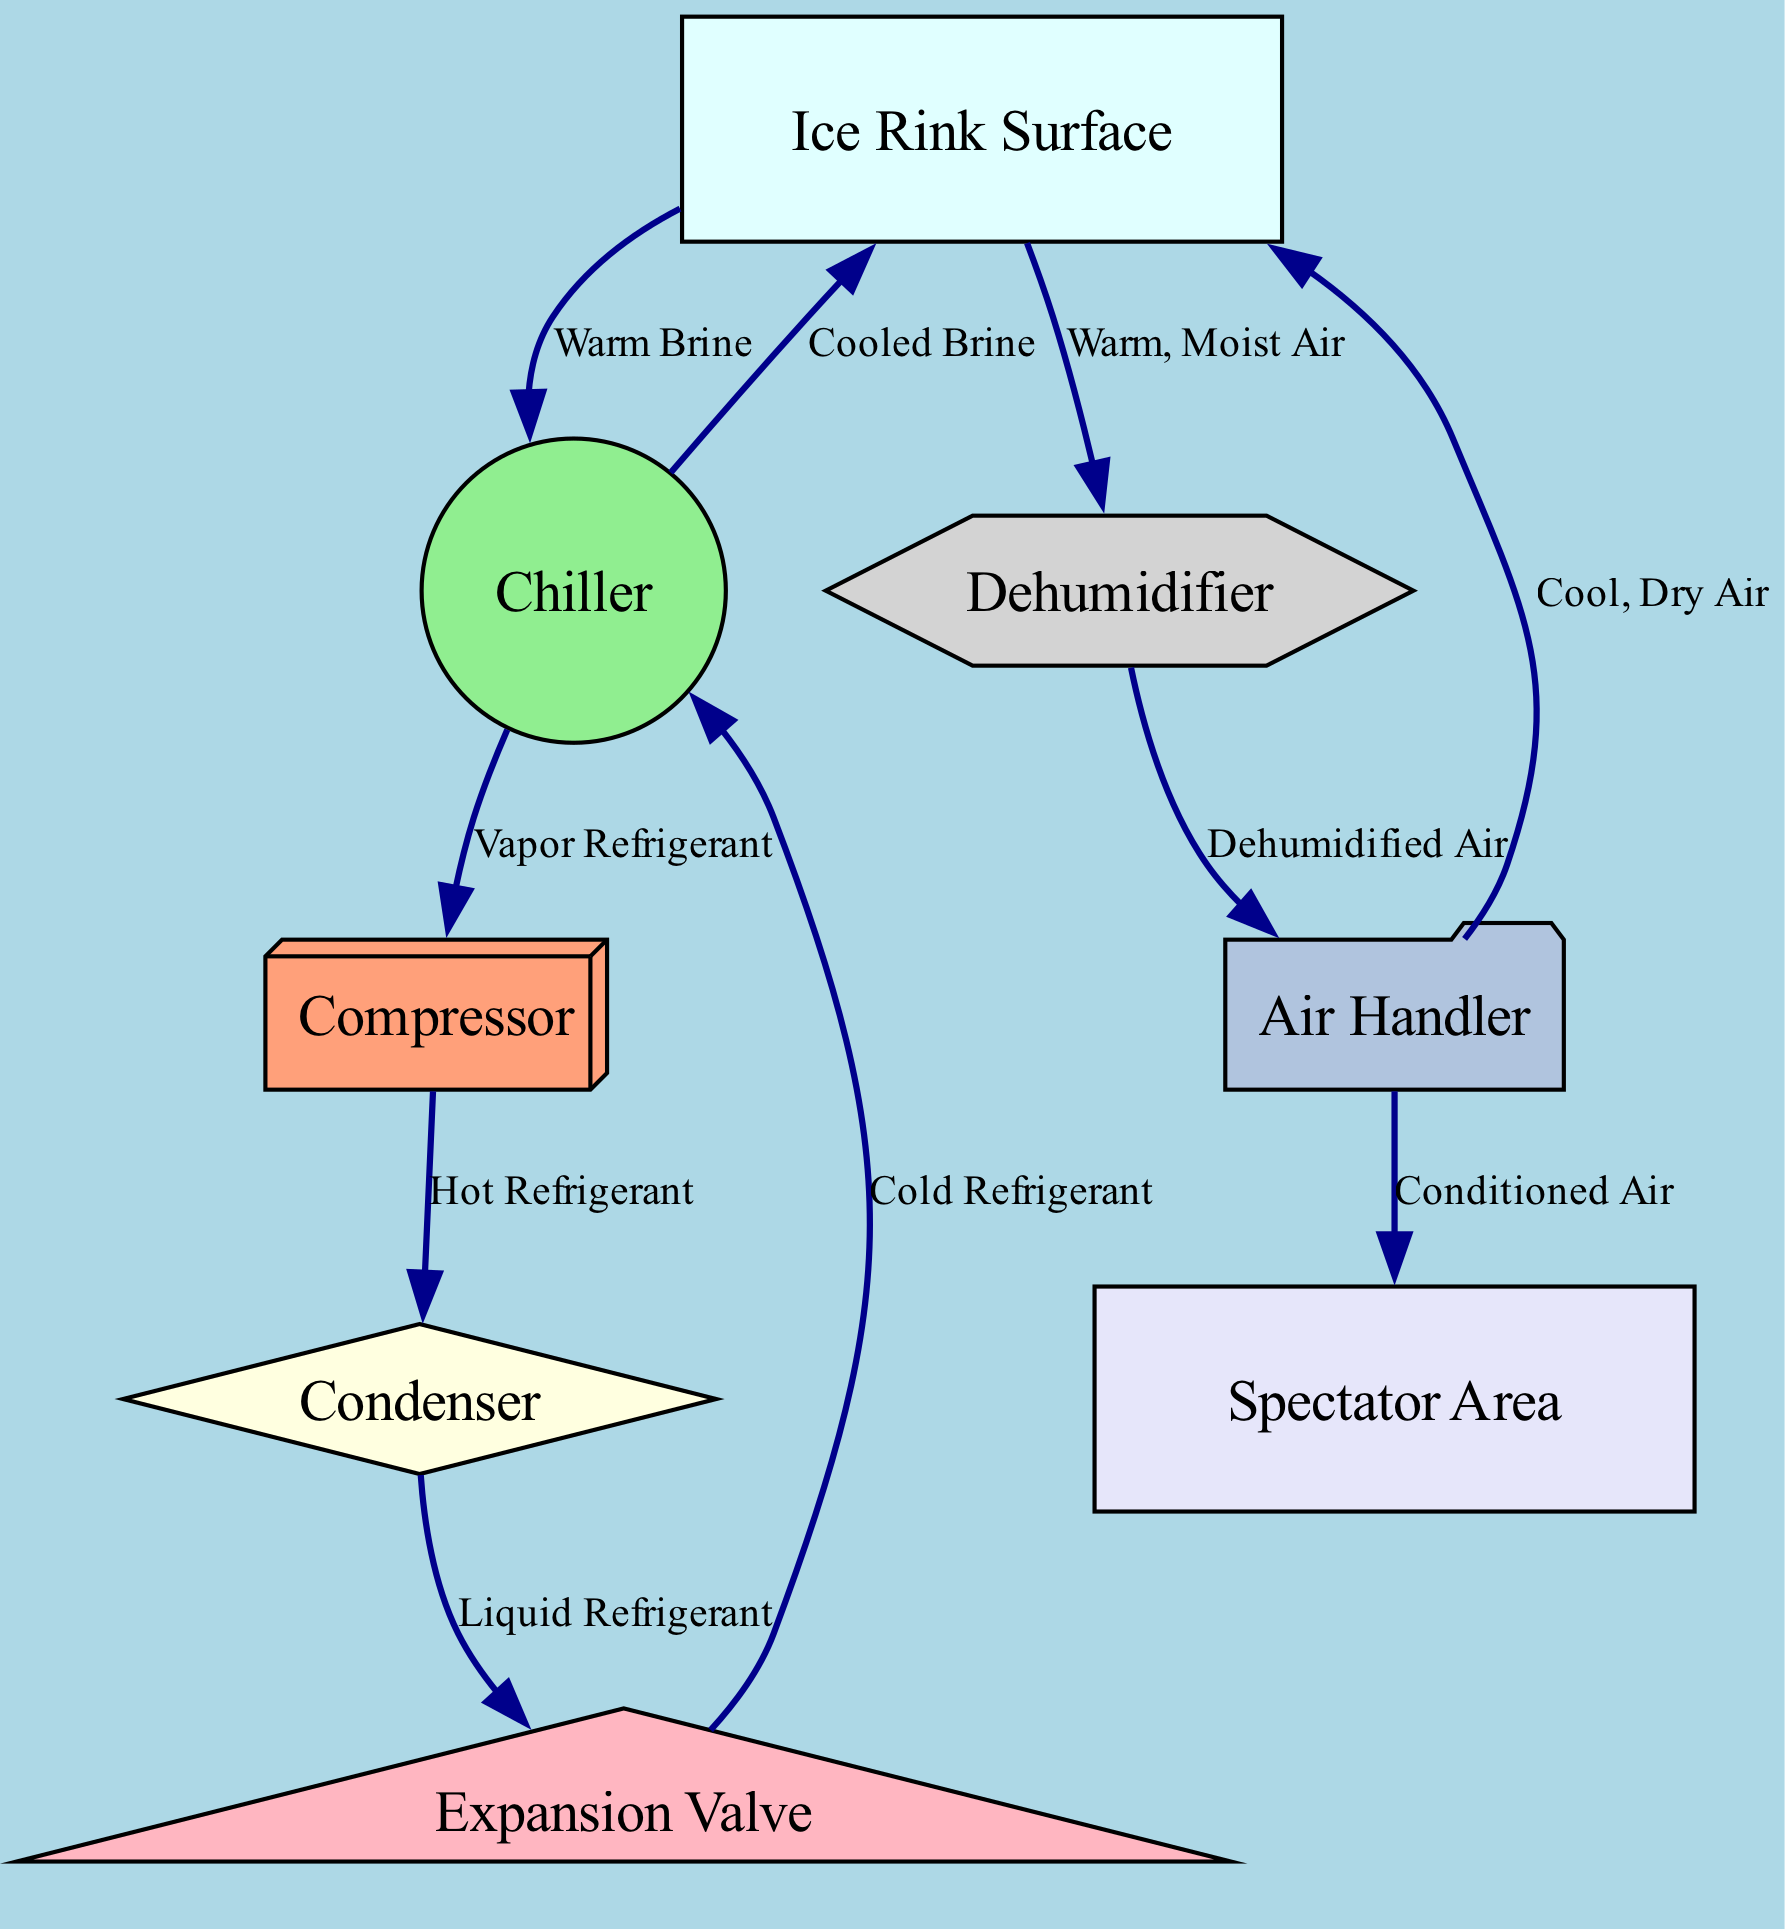What is the main purpose of the Chiller? The Chiller is responsible for cooling brine, which is then circulated to the Ice Rink Surface, contributing to maintaining the cold temperature required for ice skating.
Answer: Cooling brine What type of air is supplied to the Ice Rink Surface by the Air Handler? The Air Handler supplies cool, dry air to the Ice Rink Surface, helping to maintain a comfortable environment for skaters and spectators.
Answer: Cool, dry air How many nodes are present in the diagram? By counting all the entities represented in the diagram, including the ice rink, cooling system components, and spectator area, we find that there are eight nodes.
Answer: Eight What happens to the warm, moist air after leaving the Ice Rink Surface? The warm, moist air from the Ice Rink Surface is directed into the dehumidifier, where it is processed to remove moisture.
Answer: Dehumidifier Which component receives the cold refrigerant from the Expansion Valve? The cold refrigerant flows directly to the Chiller after passing through the Expansion Valve, which reduces its pressure and temperature.
Answer: Chiller What type of air does the Dehumidifier output? The Dehumidifier processes warm, moist air and outputs dehumidified air, which is then circulated back into the Air Handler for conditioning.
Answer: Dehumidified air How is hot refrigerant created in the system? The hot refrigerant is produced when the compressor compresses the vapor refrigerant, increasing its pressure and temperature before it moves to the condenser.
Answer: Compressor Which direction does the warm brine flow in the system? The warm brine flows from the Ice Rink Surface back to the Chiller, where it will be cooled again for circulation.
Answer: To the Chiller What is the final destination of the conditioned air from the Air Handler? The conditioned air produced by the Air Handler is directed to the Spectator Area, providing a comfortable environment for viewers of the skating events.
Answer: Spectator Area 